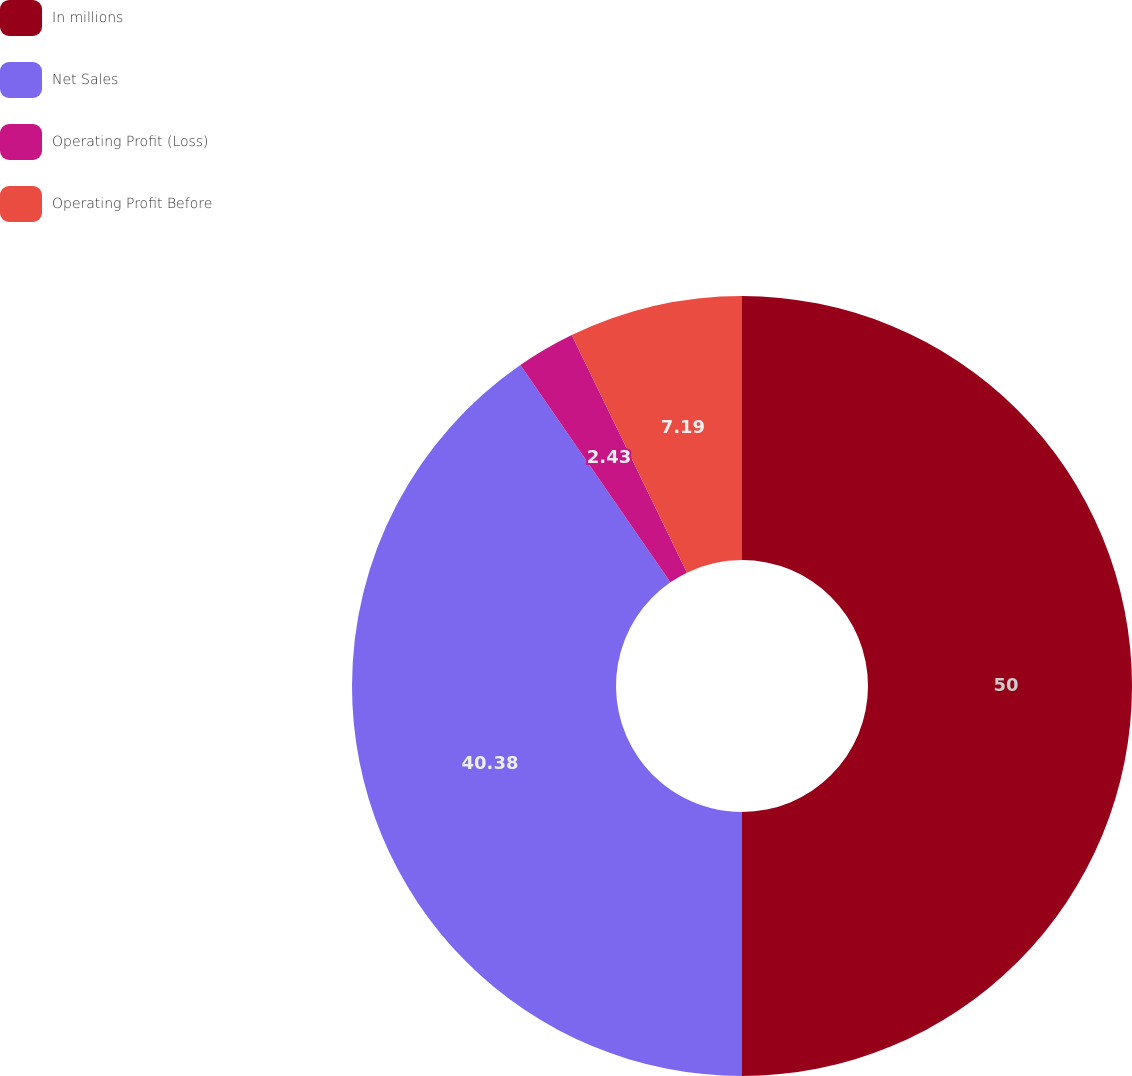Convert chart. <chart><loc_0><loc_0><loc_500><loc_500><pie_chart><fcel>In millions<fcel>Net Sales<fcel>Operating Profit (Loss)<fcel>Operating Profit Before<nl><fcel>50.0%<fcel>40.38%<fcel>2.43%<fcel>7.19%<nl></chart> 